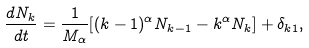<formula> <loc_0><loc_0><loc_500><loc_500>\frac { d N _ { k } } { d t } = \frac { 1 } { M _ { \alpha } } [ ( k - 1 ) ^ { \alpha } N _ { k - 1 } - k ^ { \alpha } N _ { k } ] + \delta _ { k 1 } ,</formula> 